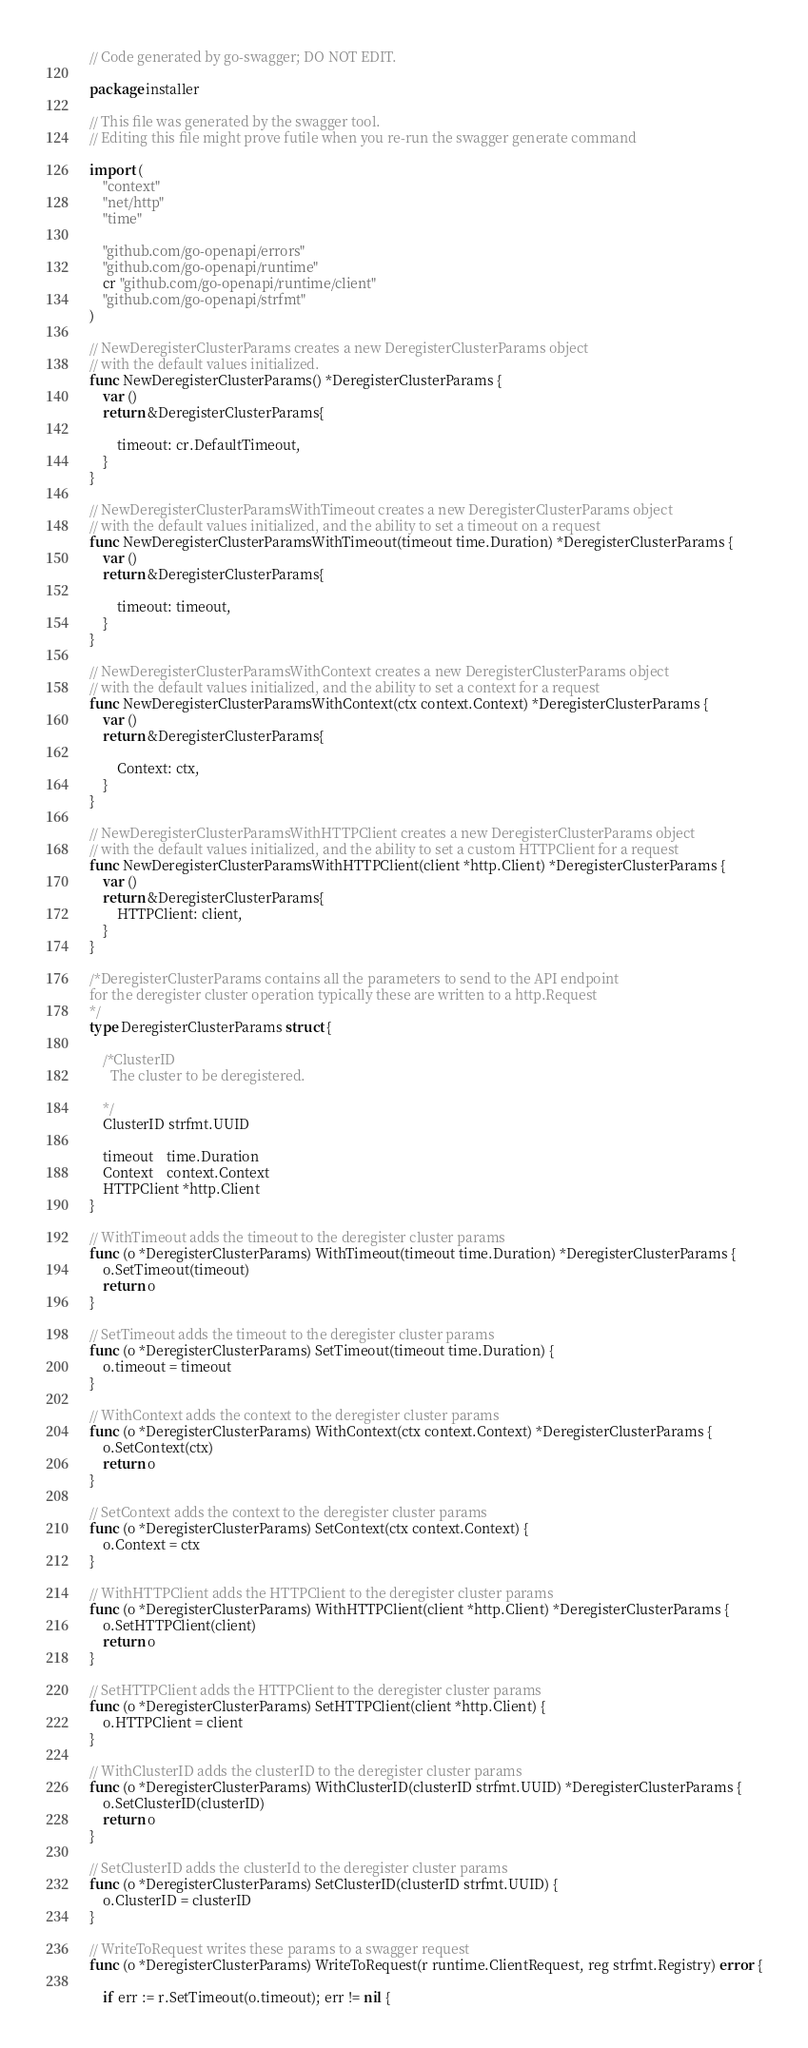Convert code to text. <code><loc_0><loc_0><loc_500><loc_500><_Go_>// Code generated by go-swagger; DO NOT EDIT.

package installer

// This file was generated by the swagger tool.
// Editing this file might prove futile when you re-run the swagger generate command

import (
	"context"
	"net/http"
	"time"

	"github.com/go-openapi/errors"
	"github.com/go-openapi/runtime"
	cr "github.com/go-openapi/runtime/client"
	"github.com/go-openapi/strfmt"
)

// NewDeregisterClusterParams creates a new DeregisterClusterParams object
// with the default values initialized.
func NewDeregisterClusterParams() *DeregisterClusterParams {
	var ()
	return &DeregisterClusterParams{

		timeout: cr.DefaultTimeout,
	}
}

// NewDeregisterClusterParamsWithTimeout creates a new DeregisterClusterParams object
// with the default values initialized, and the ability to set a timeout on a request
func NewDeregisterClusterParamsWithTimeout(timeout time.Duration) *DeregisterClusterParams {
	var ()
	return &DeregisterClusterParams{

		timeout: timeout,
	}
}

// NewDeregisterClusterParamsWithContext creates a new DeregisterClusterParams object
// with the default values initialized, and the ability to set a context for a request
func NewDeregisterClusterParamsWithContext(ctx context.Context) *DeregisterClusterParams {
	var ()
	return &DeregisterClusterParams{

		Context: ctx,
	}
}

// NewDeregisterClusterParamsWithHTTPClient creates a new DeregisterClusterParams object
// with the default values initialized, and the ability to set a custom HTTPClient for a request
func NewDeregisterClusterParamsWithHTTPClient(client *http.Client) *DeregisterClusterParams {
	var ()
	return &DeregisterClusterParams{
		HTTPClient: client,
	}
}

/*DeregisterClusterParams contains all the parameters to send to the API endpoint
for the deregister cluster operation typically these are written to a http.Request
*/
type DeregisterClusterParams struct {

	/*ClusterID
	  The cluster to be deregistered.

	*/
	ClusterID strfmt.UUID

	timeout    time.Duration
	Context    context.Context
	HTTPClient *http.Client
}

// WithTimeout adds the timeout to the deregister cluster params
func (o *DeregisterClusterParams) WithTimeout(timeout time.Duration) *DeregisterClusterParams {
	o.SetTimeout(timeout)
	return o
}

// SetTimeout adds the timeout to the deregister cluster params
func (o *DeregisterClusterParams) SetTimeout(timeout time.Duration) {
	o.timeout = timeout
}

// WithContext adds the context to the deregister cluster params
func (o *DeregisterClusterParams) WithContext(ctx context.Context) *DeregisterClusterParams {
	o.SetContext(ctx)
	return o
}

// SetContext adds the context to the deregister cluster params
func (o *DeregisterClusterParams) SetContext(ctx context.Context) {
	o.Context = ctx
}

// WithHTTPClient adds the HTTPClient to the deregister cluster params
func (o *DeregisterClusterParams) WithHTTPClient(client *http.Client) *DeregisterClusterParams {
	o.SetHTTPClient(client)
	return o
}

// SetHTTPClient adds the HTTPClient to the deregister cluster params
func (o *DeregisterClusterParams) SetHTTPClient(client *http.Client) {
	o.HTTPClient = client
}

// WithClusterID adds the clusterID to the deregister cluster params
func (o *DeregisterClusterParams) WithClusterID(clusterID strfmt.UUID) *DeregisterClusterParams {
	o.SetClusterID(clusterID)
	return o
}

// SetClusterID adds the clusterId to the deregister cluster params
func (o *DeregisterClusterParams) SetClusterID(clusterID strfmt.UUID) {
	o.ClusterID = clusterID
}

// WriteToRequest writes these params to a swagger request
func (o *DeregisterClusterParams) WriteToRequest(r runtime.ClientRequest, reg strfmt.Registry) error {

	if err := r.SetTimeout(o.timeout); err != nil {</code> 